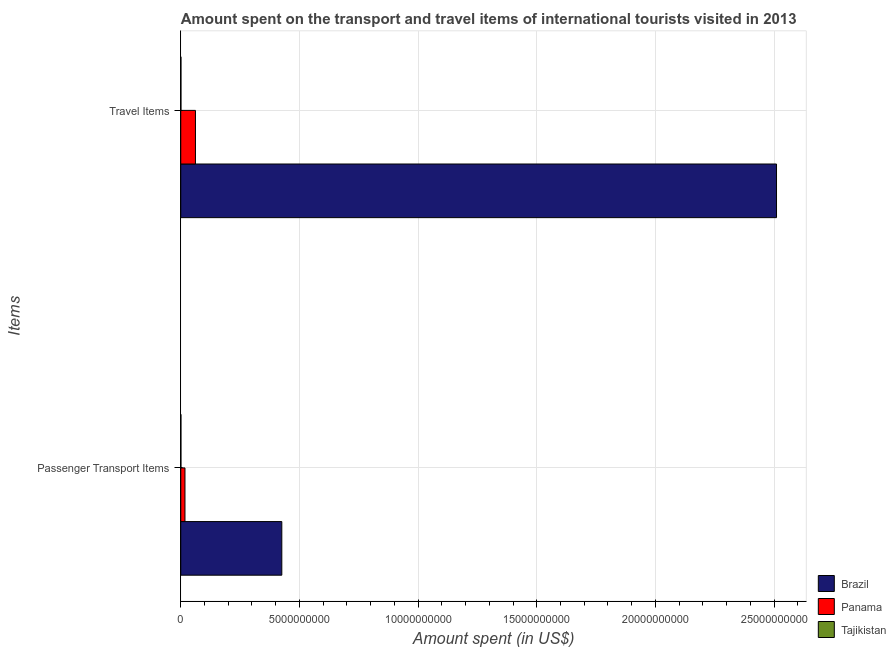How many different coloured bars are there?
Offer a terse response. 3. How many groups of bars are there?
Keep it short and to the point. 2. Are the number of bars per tick equal to the number of legend labels?
Ensure brevity in your answer.  Yes. Are the number of bars on each tick of the Y-axis equal?
Keep it short and to the point. Yes. How many bars are there on the 1st tick from the top?
Ensure brevity in your answer.  3. How many bars are there on the 1st tick from the bottom?
Keep it short and to the point. 3. What is the label of the 2nd group of bars from the top?
Give a very brief answer. Passenger Transport Items. What is the amount spent on passenger transport items in Brazil?
Provide a short and direct response. 4.26e+09. Across all countries, what is the maximum amount spent in travel items?
Provide a short and direct response. 2.51e+1. Across all countries, what is the minimum amount spent in travel items?
Provide a short and direct response. 7.20e+06. In which country was the amount spent on passenger transport items maximum?
Your answer should be very brief. Brazil. In which country was the amount spent in travel items minimum?
Your response must be concise. Tajikistan. What is the total amount spent in travel items in the graph?
Make the answer very short. 2.57e+1. What is the difference between the amount spent on passenger transport items in Panama and that in Brazil?
Keep it short and to the point. -4.08e+09. What is the difference between the amount spent in travel items in Tajikistan and the amount spent on passenger transport items in Panama?
Make the answer very short. -1.70e+08. What is the average amount spent on passenger transport items per country?
Offer a terse response. 1.48e+09. What is the difference between the amount spent on passenger transport items and amount spent in travel items in Brazil?
Provide a short and direct response. -2.08e+1. What is the ratio of the amount spent in travel items in Brazil to that in Tajikistan?
Offer a very short reply. 3486.53. What does the 1st bar from the top in Travel Items represents?
Your response must be concise. Tajikistan. What does the 3rd bar from the bottom in Travel Items represents?
Ensure brevity in your answer.  Tajikistan. How many bars are there?
Ensure brevity in your answer.  6. Are all the bars in the graph horizontal?
Provide a short and direct response. Yes. Does the graph contain any zero values?
Keep it short and to the point. No. Does the graph contain grids?
Your answer should be very brief. Yes. How are the legend labels stacked?
Keep it short and to the point. Vertical. What is the title of the graph?
Your answer should be very brief. Amount spent on the transport and travel items of international tourists visited in 2013. Does "Sudan" appear as one of the legend labels in the graph?
Offer a very short reply. No. What is the label or title of the X-axis?
Your response must be concise. Amount spent (in US$). What is the label or title of the Y-axis?
Your answer should be compact. Items. What is the Amount spent (in US$) of Brazil in Passenger Transport Items?
Offer a terse response. 4.26e+09. What is the Amount spent (in US$) in Panama in Passenger Transport Items?
Make the answer very short. 1.77e+08. What is the Amount spent (in US$) in Tajikistan in Passenger Transport Items?
Offer a very short reply. 6.90e+06. What is the Amount spent (in US$) of Brazil in Travel Items?
Your response must be concise. 2.51e+1. What is the Amount spent (in US$) in Panama in Travel Items?
Keep it short and to the point. 6.19e+08. What is the Amount spent (in US$) in Tajikistan in Travel Items?
Your answer should be very brief. 7.20e+06. Across all Items, what is the maximum Amount spent (in US$) of Brazil?
Make the answer very short. 2.51e+1. Across all Items, what is the maximum Amount spent (in US$) of Panama?
Your answer should be compact. 6.19e+08. Across all Items, what is the maximum Amount spent (in US$) in Tajikistan?
Provide a succinct answer. 7.20e+06. Across all Items, what is the minimum Amount spent (in US$) in Brazil?
Your answer should be compact. 4.26e+09. Across all Items, what is the minimum Amount spent (in US$) of Panama?
Your answer should be very brief. 1.77e+08. Across all Items, what is the minimum Amount spent (in US$) in Tajikistan?
Your answer should be compact. 6.90e+06. What is the total Amount spent (in US$) in Brazil in the graph?
Your answer should be very brief. 2.94e+1. What is the total Amount spent (in US$) in Panama in the graph?
Ensure brevity in your answer.  7.96e+08. What is the total Amount spent (in US$) in Tajikistan in the graph?
Make the answer very short. 1.41e+07. What is the difference between the Amount spent (in US$) of Brazil in Passenger Transport Items and that in Travel Items?
Provide a short and direct response. -2.08e+1. What is the difference between the Amount spent (in US$) of Panama in Passenger Transport Items and that in Travel Items?
Offer a very short reply. -4.42e+08. What is the difference between the Amount spent (in US$) of Brazil in Passenger Transport Items and the Amount spent (in US$) of Panama in Travel Items?
Keep it short and to the point. 3.64e+09. What is the difference between the Amount spent (in US$) in Brazil in Passenger Transport Items and the Amount spent (in US$) in Tajikistan in Travel Items?
Provide a short and direct response. 4.25e+09. What is the difference between the Amount spent (in US$) in Panama in Passenger Transport Items and the Amount spent (in US$) in Tajikistan in Travel Items?
Your response must be concise. 1.70e+08. What is the average Amount spent (in US$) of Brazil per Items?
Provide a short and direct response. 1.47e+1. What is the average Amount spent (in US$) in Panama per Items?
Provide a succinct answer. 3.98e+08. What is the average Amount spent (in US$) in Tajikistan per Items?
Provide a short and direct response. 7.05e+06. What is the difference between the Amount spent (in US$) of Brazil and Amount spent (in US$) of Panama in Passenger Transport Items?
Provide a short and direct response. 4.08e+09. What is the difference between the Amount spent (in US$) in Brazil and Amount spent (in US$) in Tajikistan in Passenger Transport Items?
Your answer should be compact. 4.25e+09. What is the difference between the Amount spent (in US$) of Panama and Amount spent (in US$) of Tajikistan in Passenger Transport Items?
Your answer should be very brief. 1.70e+08. What is the difference between the Amount spent (in US$) in Brazil and Amount spent (in US$) in Panama in Travel Items?
Provide a short and direct response. 2.45e+1. What is the difference between the Amount spent (in US$) of Brazil and Amount spent (in US$) of Tajikistan in Travel Items?
Your answer should be very brief. 2.51e+1. What is the difference between the Amount spent (in US$) of Panama and Amount spent (in US$) of Tajikistan in Travel Items?
Give a very brief answer. 6.12e+08. What is the ratio of the Amount spent (in US$) in Brazil in Passenger Transport Items to that in Travel Items?
Offer a terse response. 0.17. What is the ratio of the Amount spent (in US$) of Panama in Passenger Transport Items to that in Travel Items?
Your answer should be compact. 0.29. What is the ratio of the Amount spent (in US$) of Tajikistan in Passenger Transport Items to that in Travel Items?
Keep it short and to the point. 0.96. What is the difference between the highest and the second highest Amount spent (in US$) in Brazil?
Your answer should be very brief. 2.08e+1. What is the difference between the highest and the second highest Amount spent (in US$) of Panama?
Provide a short and direct response. 4.42e+08. What is the difference between the highest and the second highest Amount spent (in US$) of Tajikistan?
Offer a terse response. 3.00e+05. What is the difference between the highest and the lowest Amount spent (in US$) of Brazil?
Provide a succinct answer. 2.08e+1. What is the difference between the highest and the lowest Amount spent (in US$) of Panama?
Provide a short and direct response. 4.42e+08. 